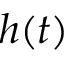Convert formula to latex. <formula><loc_0><loc_0><loc_500><loc_500>h ( t )</formula> 